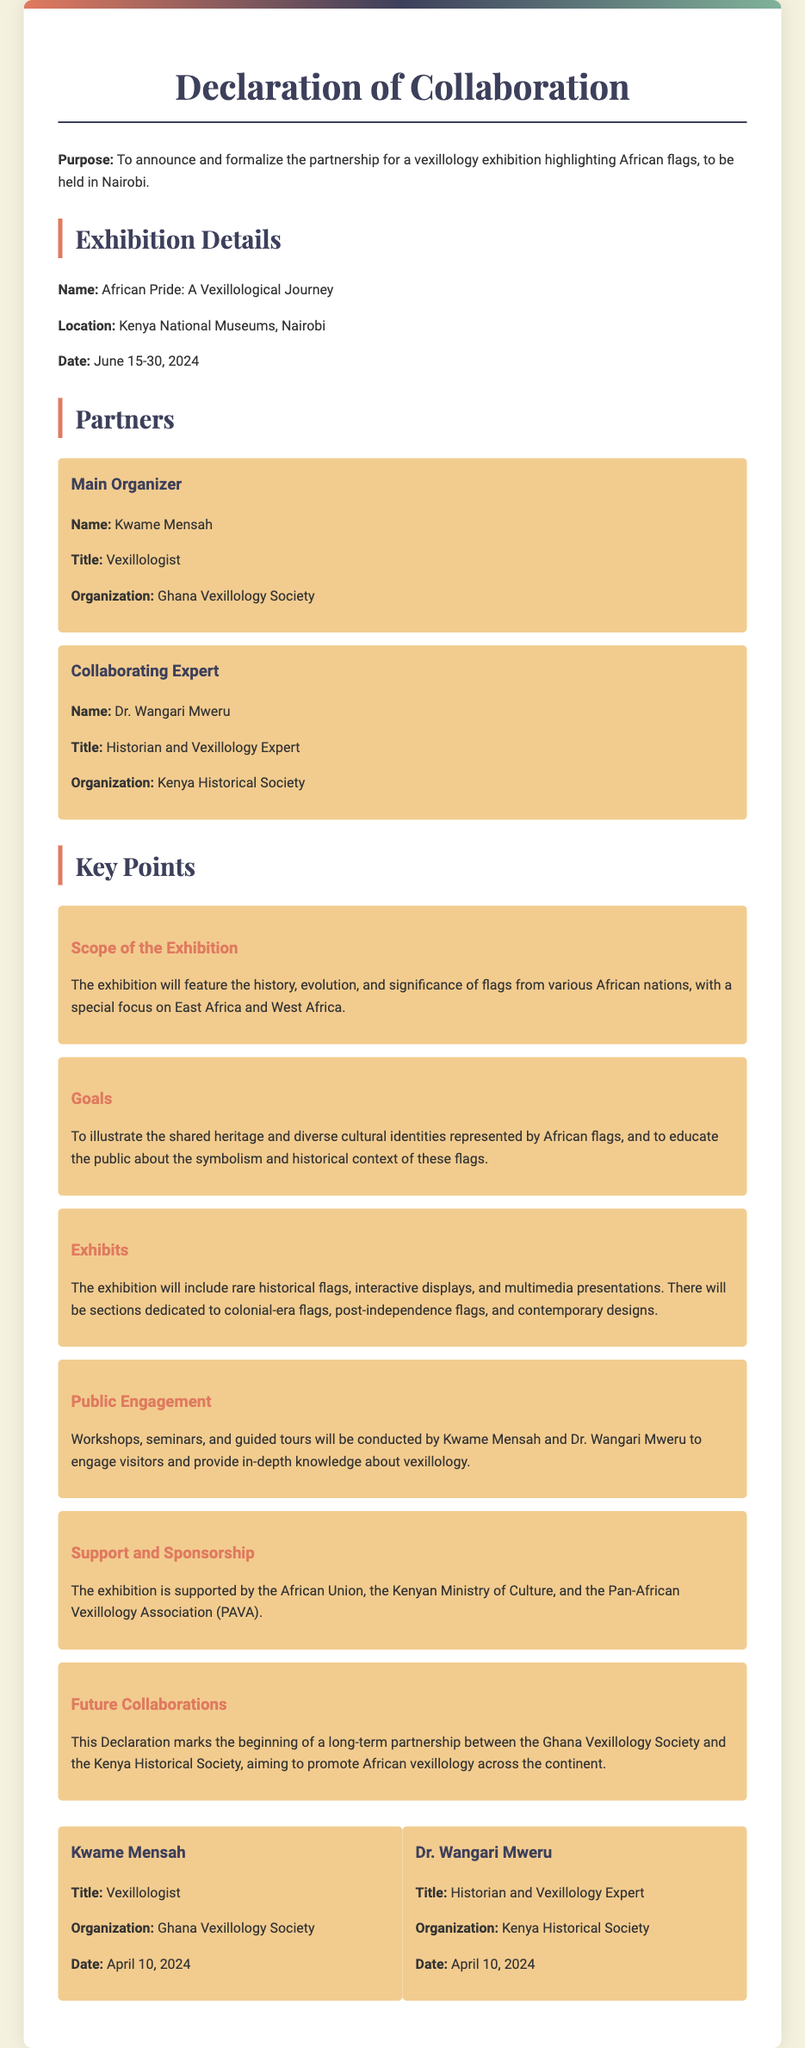What is the purpose of the Declaration? The purpose outlined in the Declaration is to announce and formalize the partnership for a vexillology exhibition highlighting African flags, to be held in Nairobi.
Answer: To announce and formalize the partnership for a vexillology exhibition highlighting African flags What is the name of the exhibition? The name of the exhibition is explicitly stated in the document.
Answer: African Pride: A Vexillological Journey Where is the exhibition located? The location is detailed in the document.
Answer: Kenya National Museums, Nairobi When will the exhibition take place? The date of the exhibition is provided in the Declaration.
Answer: June 15-30, 2024 Who is the Main Organizer of the exhibition? The document specifies the Main Organizer’s name, title, and organization.
Answer: Kwame Mensah What are the exhibition goals? The goals section states the aims of the exhibition, indicating the purpose of educating the public.
Answer: To illustrate the shared heritage and diverse cultural identities represented by African flags What support has the exhibition received? The document lists supporting organizations for the exhibition.
Answer: African Union, Kenyan Ministry of Culture, Pan-African Vexillology Association What does this Declaration signify for future collaborations? The Declaration indicates the establishment of a long-term partnership between specific organizations.
Answer: A long-term partnership between the Ghana Vexillology Society and the Kenya Historical Society 